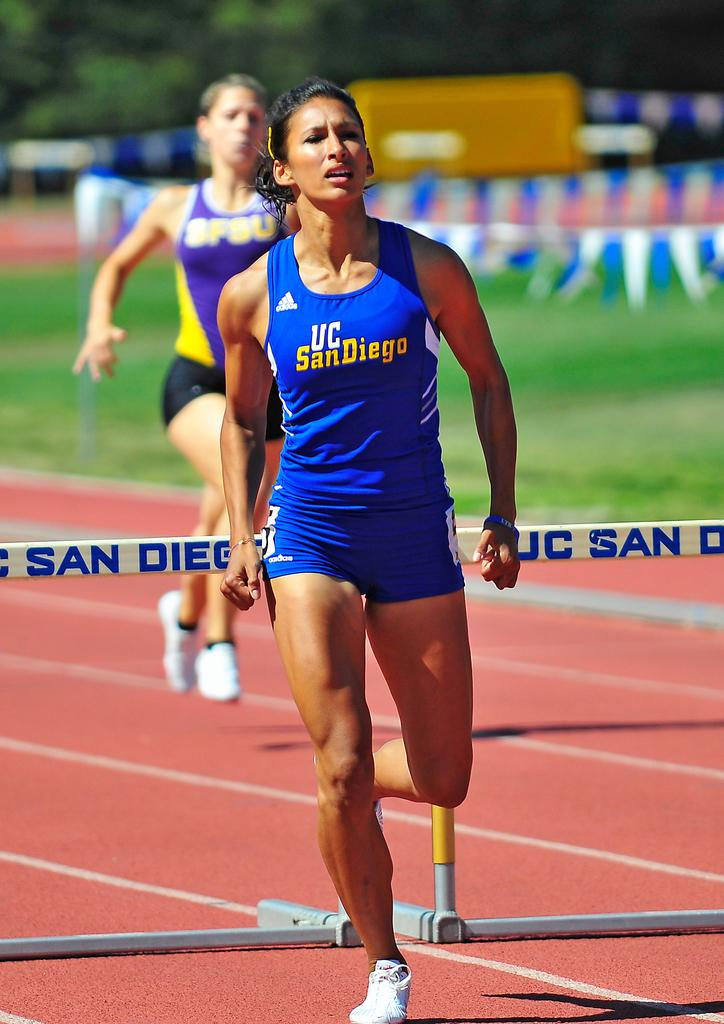What are the people in the image doing? The people in the image are running. What is located behind the people? There is fencing behind the people. What type of terrain is visible behind the fencing? There is grass visible behind the fencing. What decorative elements can be seen in the image? There are banners present in the image. What type of natural elements can be seen at the top of the image? Trees are visible at the top of the image. What type of toys are the people playing with in the image? There are no toys present in the image; the people are running. 